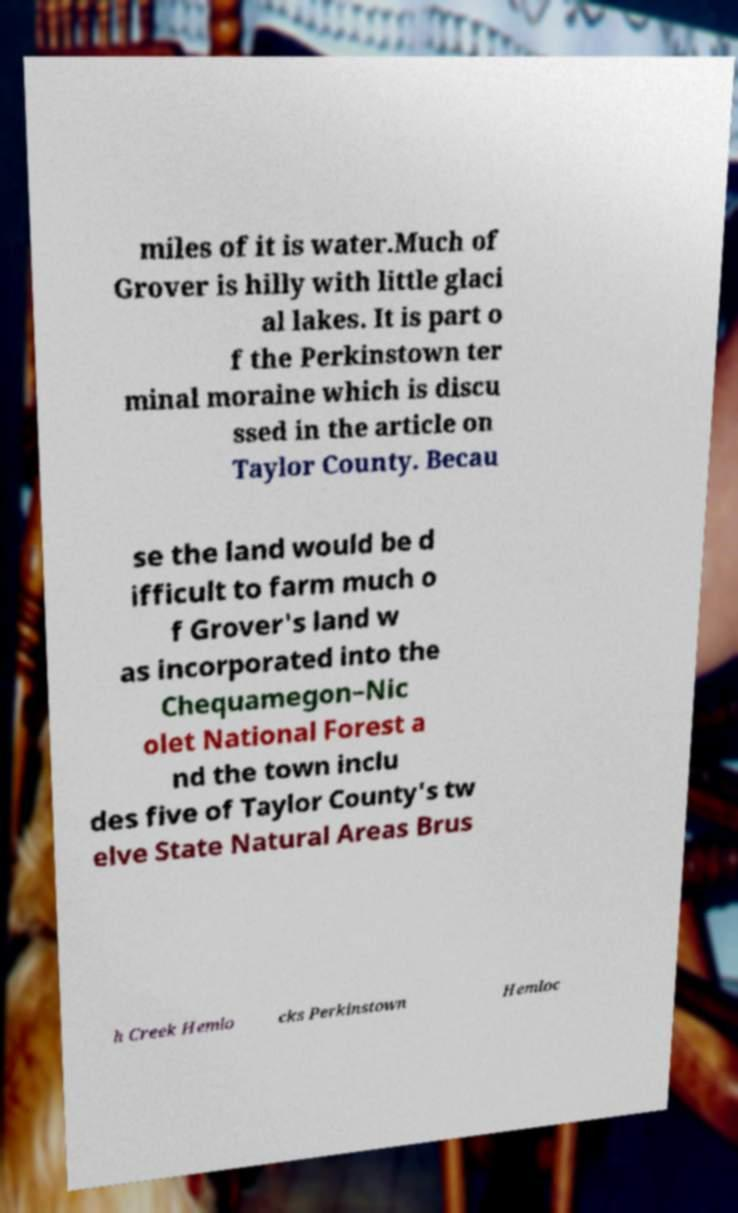Please read and relay the text visible in this image. What does it say? miles of it is water.Much of Grover is hilly with little glaci al lakes. It is part o f the Perkinstown ter minal moraine which is discu ssed in the article on Taylor County. Becau se the land would be d ifficult to farm much o f Grover's land w as incorporated into the Chequamegon–Nic olet National Forest a nd the town inclu des five of Taylor County's tw elve State Natural Areas Brus h Creek Hemlo cks Perkinstown Hemloc 